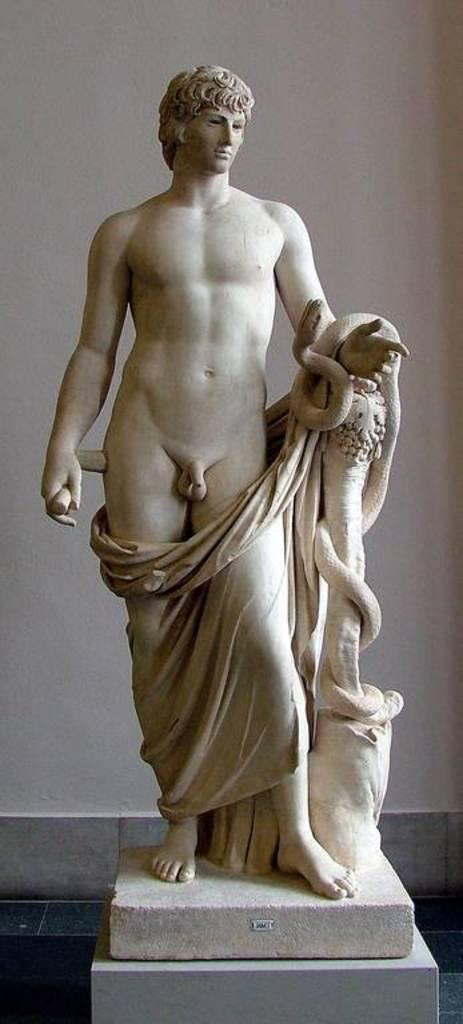What is the main subject of the image? There is a statue of a man in the image. What is the man depicted in the statue wearing? The man is nude. Are there any additional features on the statue? Yes, the statue has a cloth covering its hands. What can be seen in the background of the image? There is a wall in the background of the image. What type of surface is visible in the image? The image shows a floor. How many cars are parked next to the statue in the image? There are no cars present in the image; it only features a statue of a man. What type of horse is depicted in the image? There are no horses present in the image; it only features a statue of a man. 